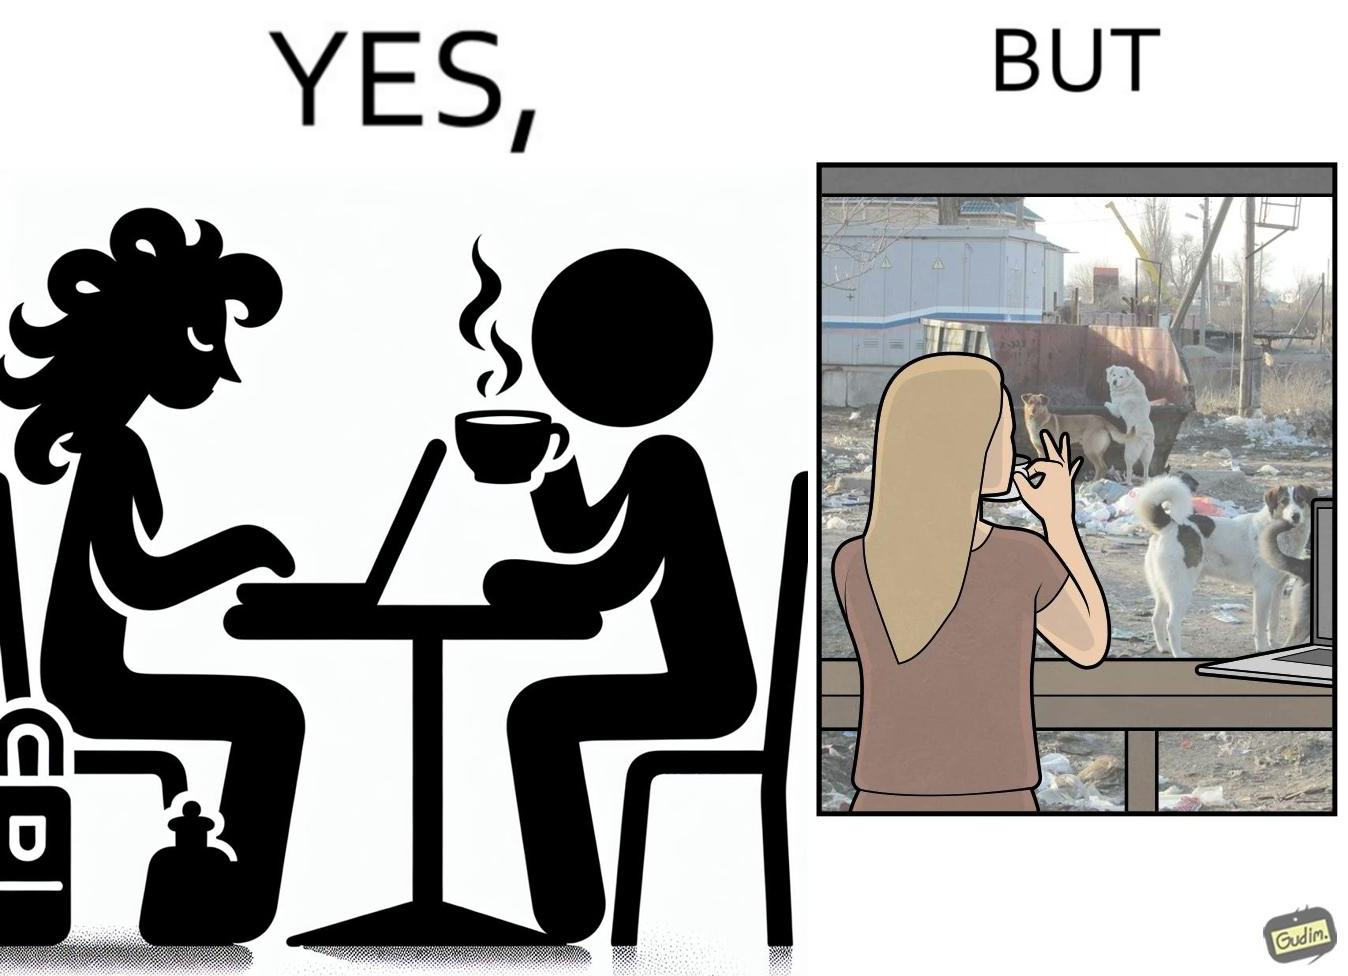Why is this image considered satirical? The people nowadays are not concerned about the surroundings, everyone is busy in their life, like in the image it is shown that even when the woman notices the issues faced by stray but even then she is not ready to raise her voice or do some action for the cause 